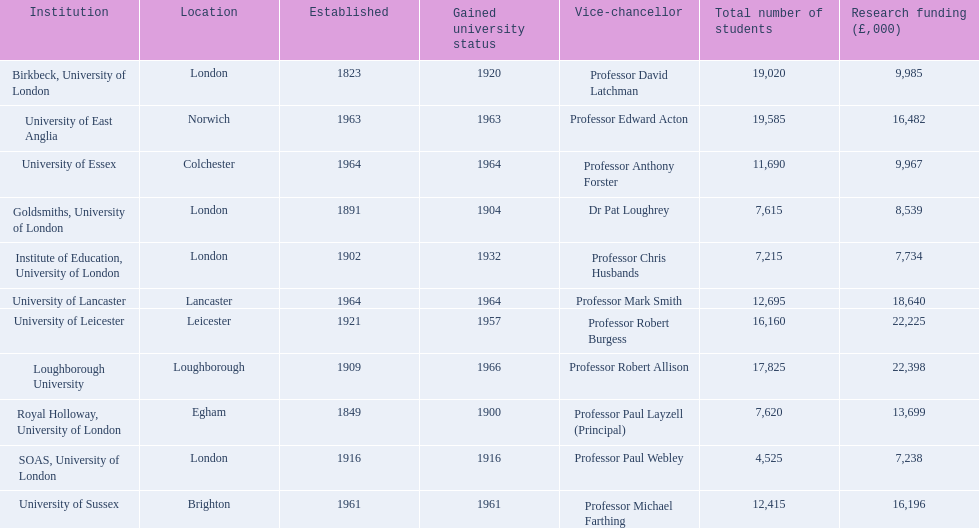What is the complete list of institutions' names? Birkbeck, University of London, University of East Anglia, University of Essex, Goldsmiths, University of London, Institute of Education, University of London, University of Lancaster, University of Leicester, Loughborough University, Royal Holloway, University of London, SOAS, University of London, University of Sussex. What is the time frame of their establishment? 1823, 1963, 1964, 1891, 1902, 1964, 1921, 1909, 1849, 1916, 1961. When did they obtain university status? 1920, 1963, 1964, 1904, 1932, 1964, 1957, 1966, 1900, 1916, 1961. Which institution was the last to be granted university status? Loughborough University. 